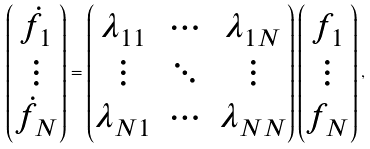Convert formula to latex. <formula><loc_0><loc_0><loc_500><loc_500>\begin{pmatrix} { \dot { f } } _ { 1 } \\ \vdots \\ { \dot { f } } _ { N } \end{pmatrix} = \begin{pmatrix} \lambda _ { 1 1 } & \cdots & \lambda _ { 1 N } \\ \vdots & \ddots & \vdots \\ \lambda _ { N 1 } & \cdots & \lambda _ { N N } \end{pmatrix} \begin{pmatrix} f _ { 1 } \\ \vdots \\ f _ { N } \end{pmatrix} ,</formula> 